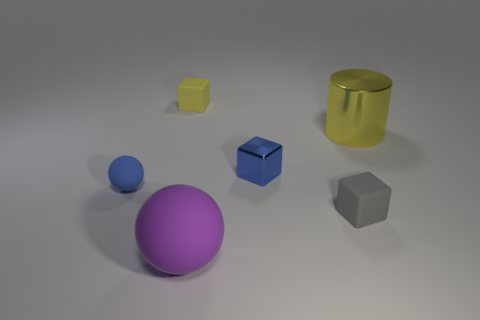Is there any indication about the size of the room or space where these objects are placed? From the image, there is no direct evidence about the size of the room or space as the edges and boundaries are not visible. The focus is solely on the objects and their arrangement on a plain surface with a slight shadow effect, which does not provide any depth cues or context for the size of the surrounding space. 